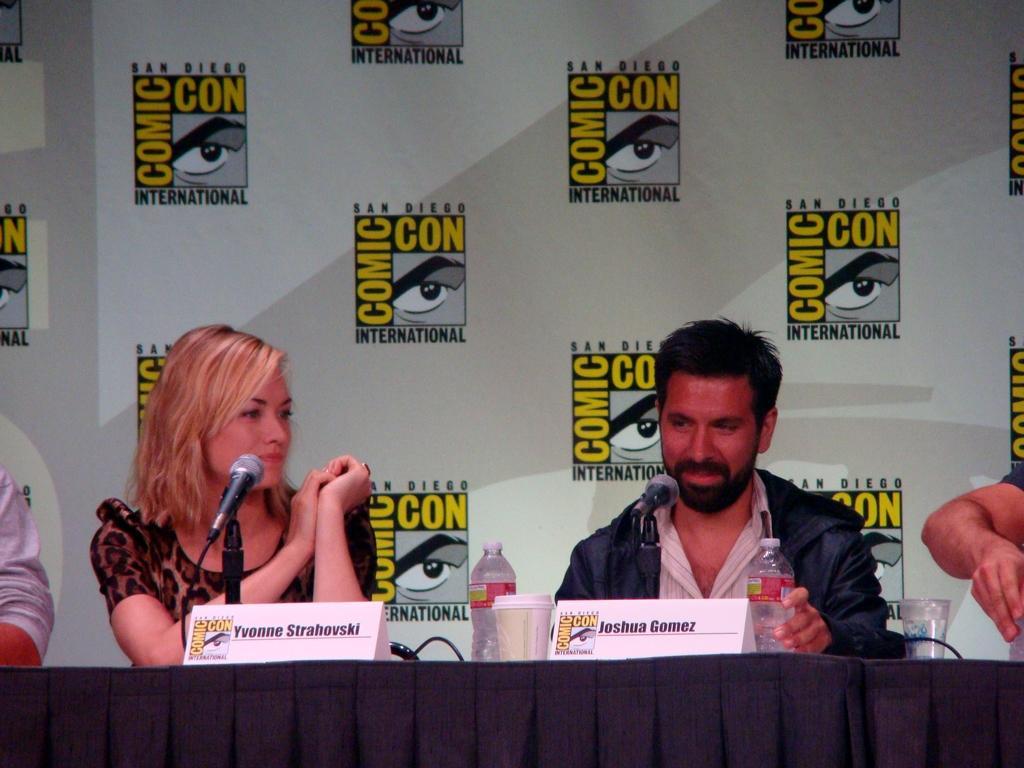How would you summarize this image in a sentence or two? In-front of these people there is a table. On this table there are bottles, cup, glass of water, name boards and mics. Background there is a hoarding. This man is holding a bottle. 